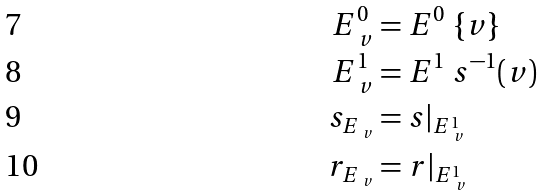Convert formula to latex. <formula><loc_0><loc_0><loc_500><loc_500>E _ { \ v } ^ { 0 } & = E ^ { 0 } \ \{ v \} \\ E _ { \ v } ^ { 1 } & = E ^ { 1 } \ s ^ { - 1 } ( v ) \\ s _ { E _ { \ v } } & = s | _ { E _ { \ v } ^ { 1 } } \\ r _ { E _ { \ v } } & = r | _ { E _ { \ v } ^ { 1 } }</formula> 